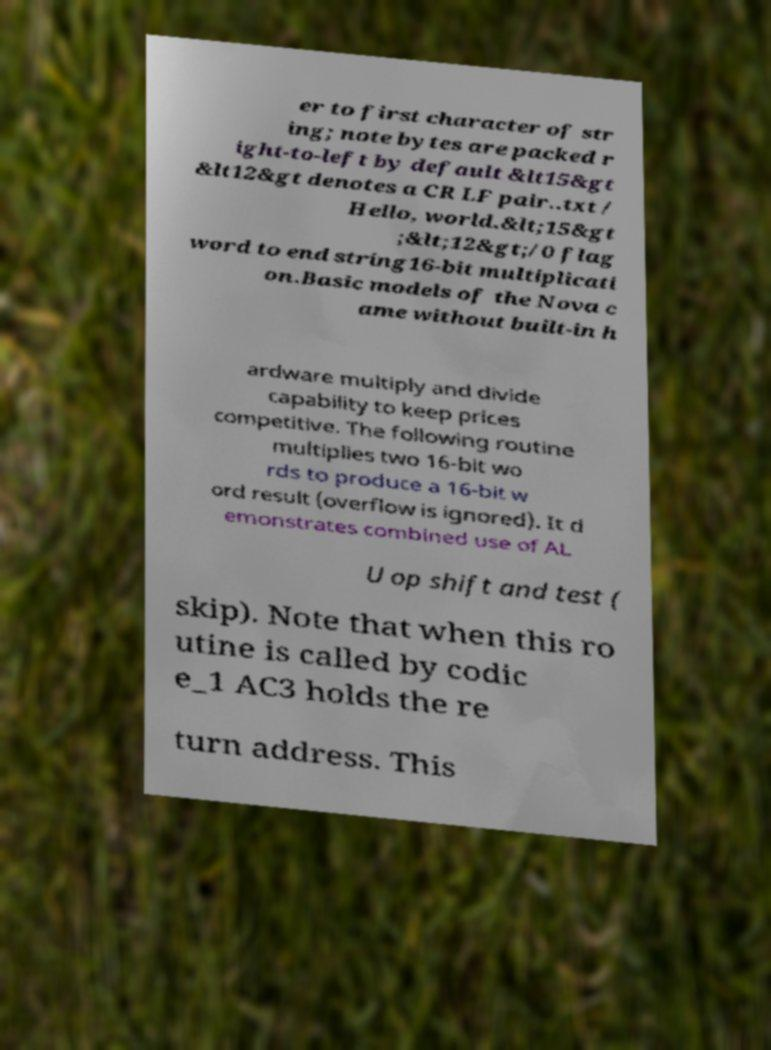Could you extract and type out the text from this image? er to first character of str ing; note bytes are packed r ight-to-left by default &lt15&gt &lt12&gt denotes a CR LF pair..txt / Hello, world.&lt;15&gt ;&lt;12&gt;/0 flag word to end string16-bit multiplicati on.Basic models of the Nova c ame without built-in h ardware multiply and divide capability to keep prices competitive. The following routine multiplies two 16-bit wo rds to produce a 16-bit w ord result (overflow is ignored). It d emonstrates combined use of AL U op shift and test ( skip). Note that when this ro utine is called by codic e_1 AC3 holds the re turn address. This 